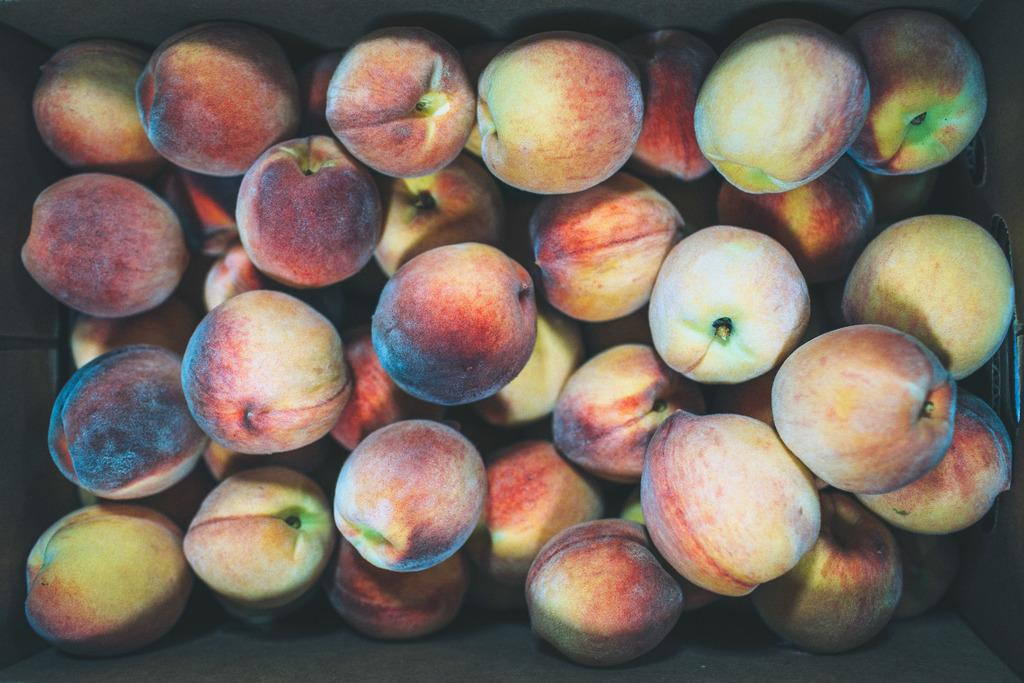What type of fruit is present in the image? There is a peach fruit in the image. Who is the owner of the boot that can be seen next to the peach fruit in the image? There is no boot or owner mentioned in the image; it only features a peach fruit. 